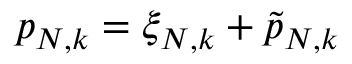Convert formula to latex. <formula><loc_0><loc_0><loc_500><loc_500>p _ { N , k } = \xi _ { N , k } + \tilde { p } _ { N , k }</formula> 